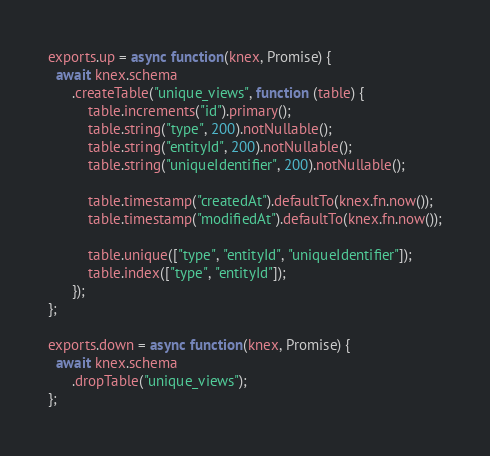<code> <loc_0><loc_0><loc_500><loc_500><_JavaScript_>
exports.up = async function(knex, Promise) {
  await knex.schema
      .createTable("unique_views", function (table) {
          table.increments("id").primary();
          table.string("type", 200).notNullable();
          table.string("entityId", 200).notNullable();
          table.string("uniqueIdentifier", 200).notNullable();

          table.timestamp("createdAt").defaultTo(knex.fn.now());
          table.timestamp("modifiedAt").defaultTo(knex.fn.now());

          table.unique(["type", "entityId", "uniqueIdentifier"]);
          table.index(["type", "entityId"]);
      });
};

exports.down = async function(knex, Promise) {
  await knex.schema
      .dropTable("unique_views");
};
</code> 